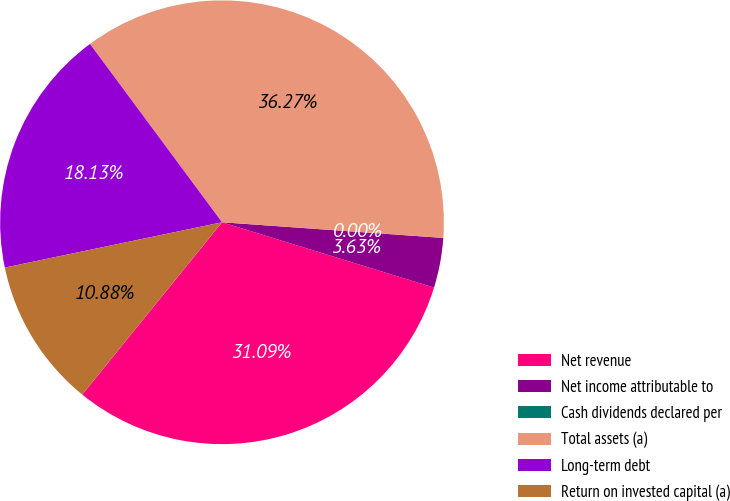Convert chart. <chart><loc_0><loc_0><loc_500><loc_500><pie_chart><fcel>Net revenue<fcel>Net income attributable to<fcel>Cash dividends declared per<fcel>Total assets (a)<fcel>Long-term debt<fcel>Return on invested capital (a)<nl><fcel>31.09%<fcel>3.63%<fcel>0.0%<fcel>36.27%<fcel>18.13%<fcel>10.88%<nl></chart> 